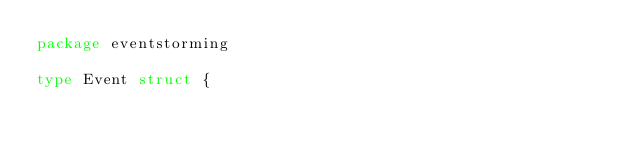<code> <loc_0><loc_0><loc_500><loc_500><_Go_>package eventstorming

type Event struct {</code> 